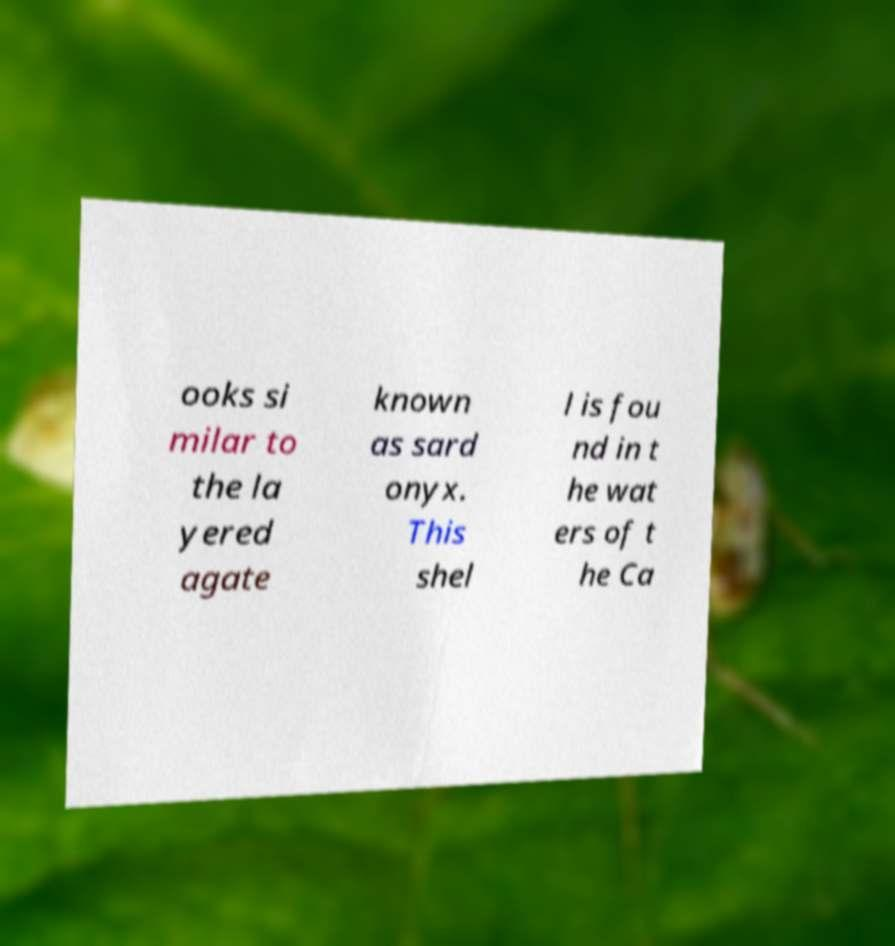Please read and relay the text visible in this image. What does it say? ooks si milar to the la yered agate known as sard onyx. This shel l is fou nd in t he wat ers of t he Ca 